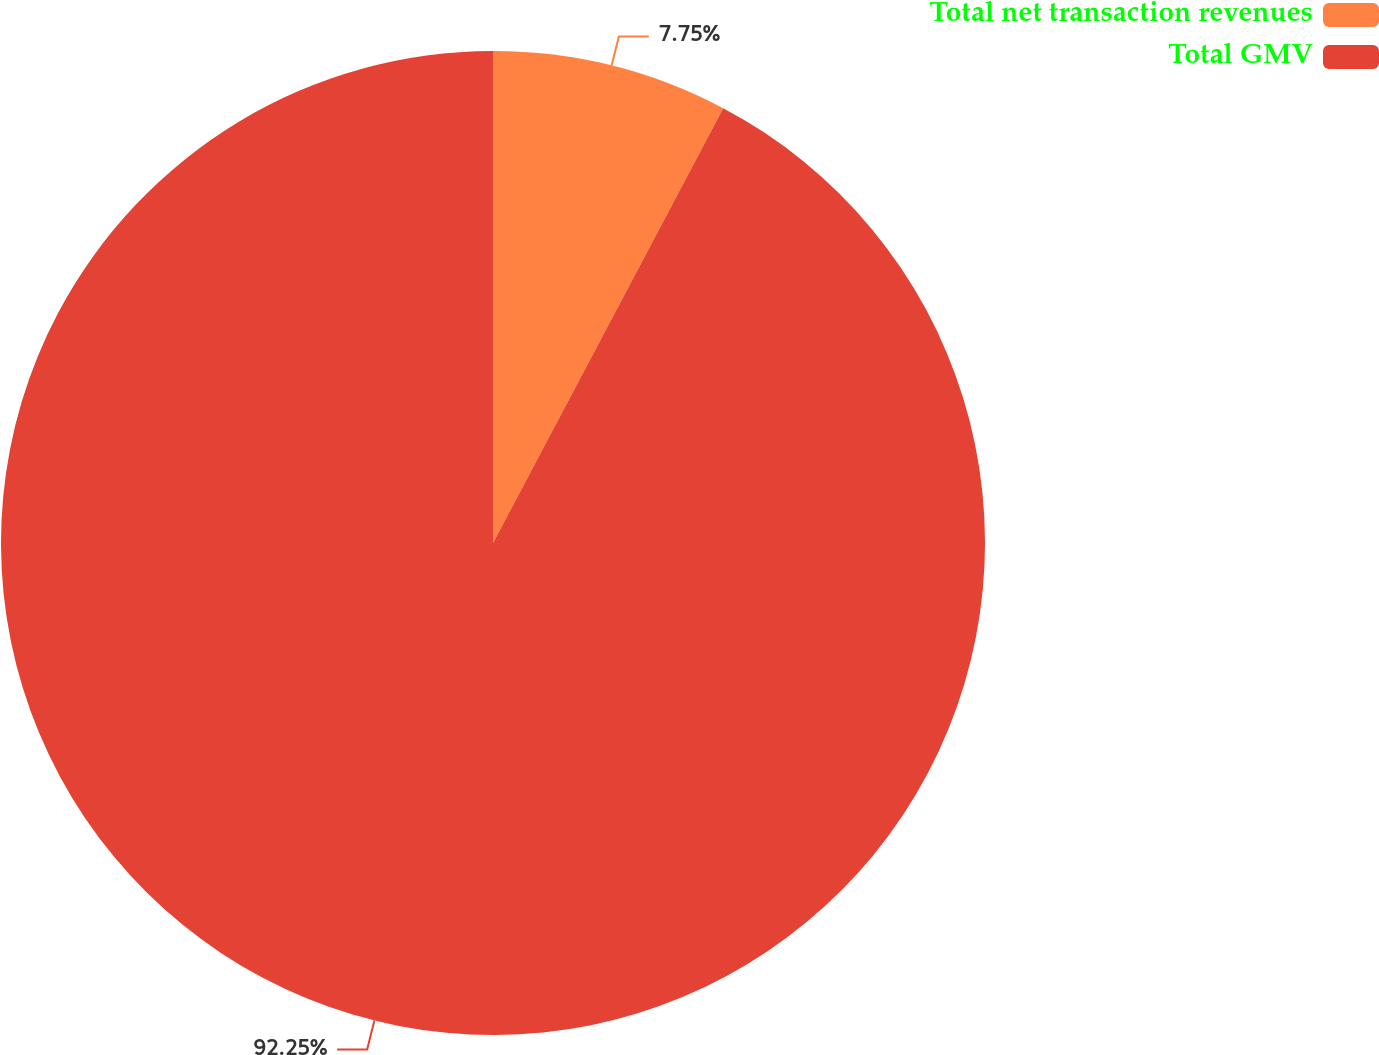<chart> <loc_0><loc_0><loc_500><loc_500><pie_chart><fcel>Total net transaction revenues<fcel>Total GMV<nl><fcel>7.75%<fcel>92.25%<nl></chart> 